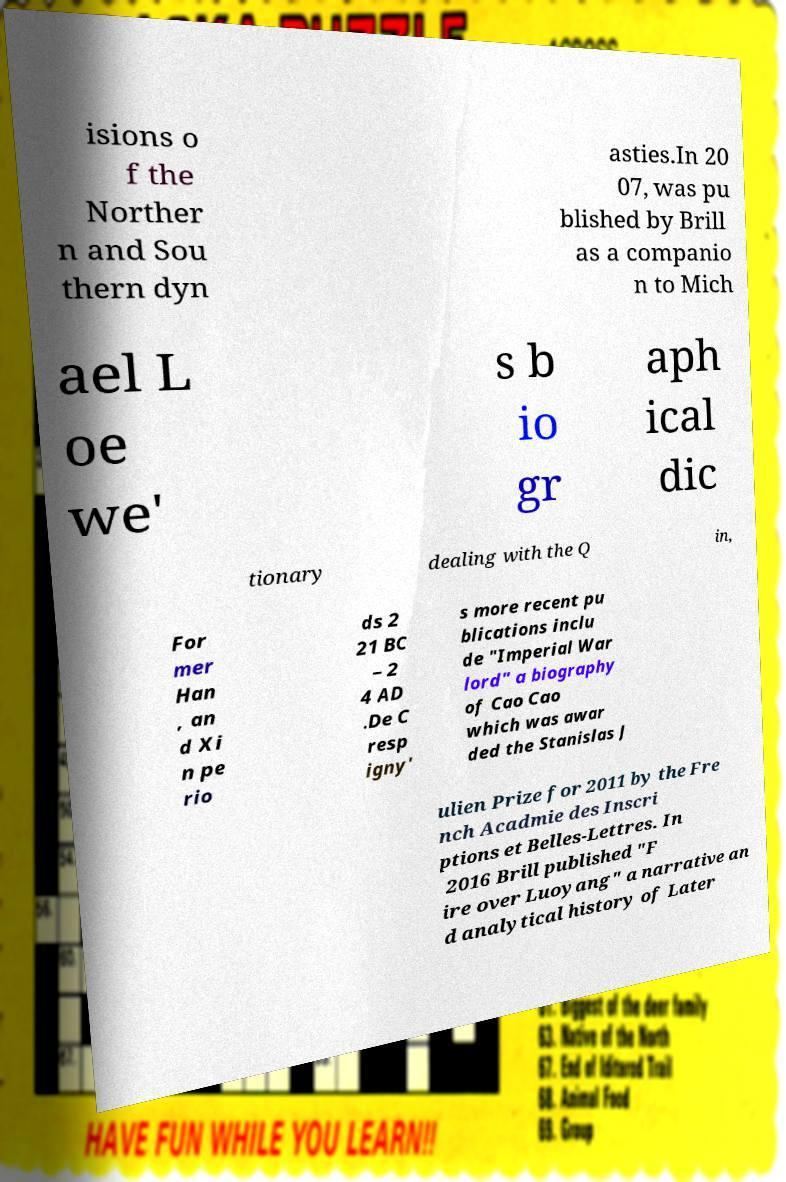Please read and relay the text visible in this image. What does it say? isions o f the Norther n and Sou thern dyn asties.In 20 07, was pu blished by Brill as a companio n to Mich ael L oe we' s b io gr aph ical dic tionary dealing with the Q in, For mer Han , an d Xi n pe rio ds 2 21 BC – 2 4 AD .De C resp igny' s more recent pu blications inclu de "Imperial War lord" a biography of Cao Cao which was awar ded the Stanislas J ulien Prize for 2011 by the Fre nch Acadmie des Inscri ptions et Belles-Lettres. In 2016 Brill published "F ire over Luoyang" a narrative an d analytical history of Later 